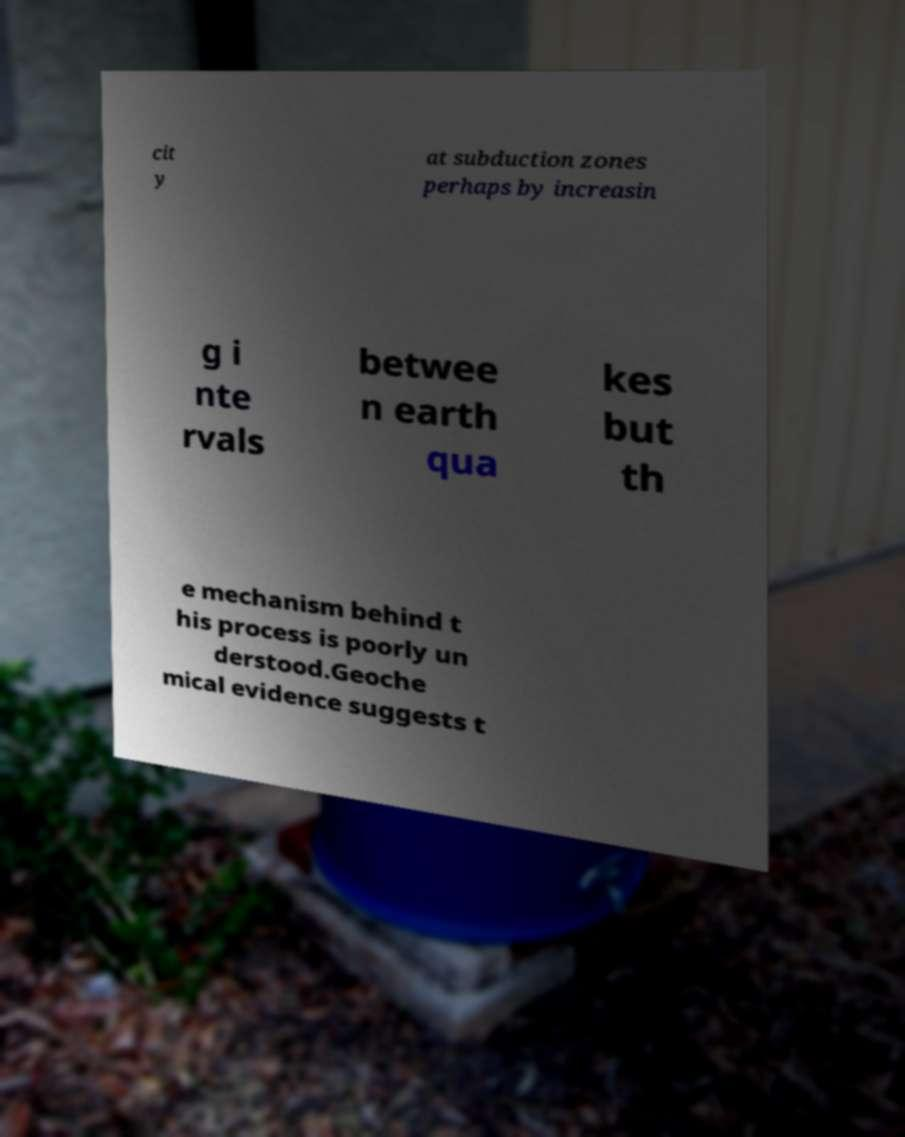Can you read and provide the text displayed in the image?This photo seems to have some interesting text. Can you extract and type it out for me? cit y at subduction zones perhaps by increasin g i nte rvals betwee n earth qua kes but th e mechanism behind t his process is poorly un derstood.Geoche mical evidence suggests t 